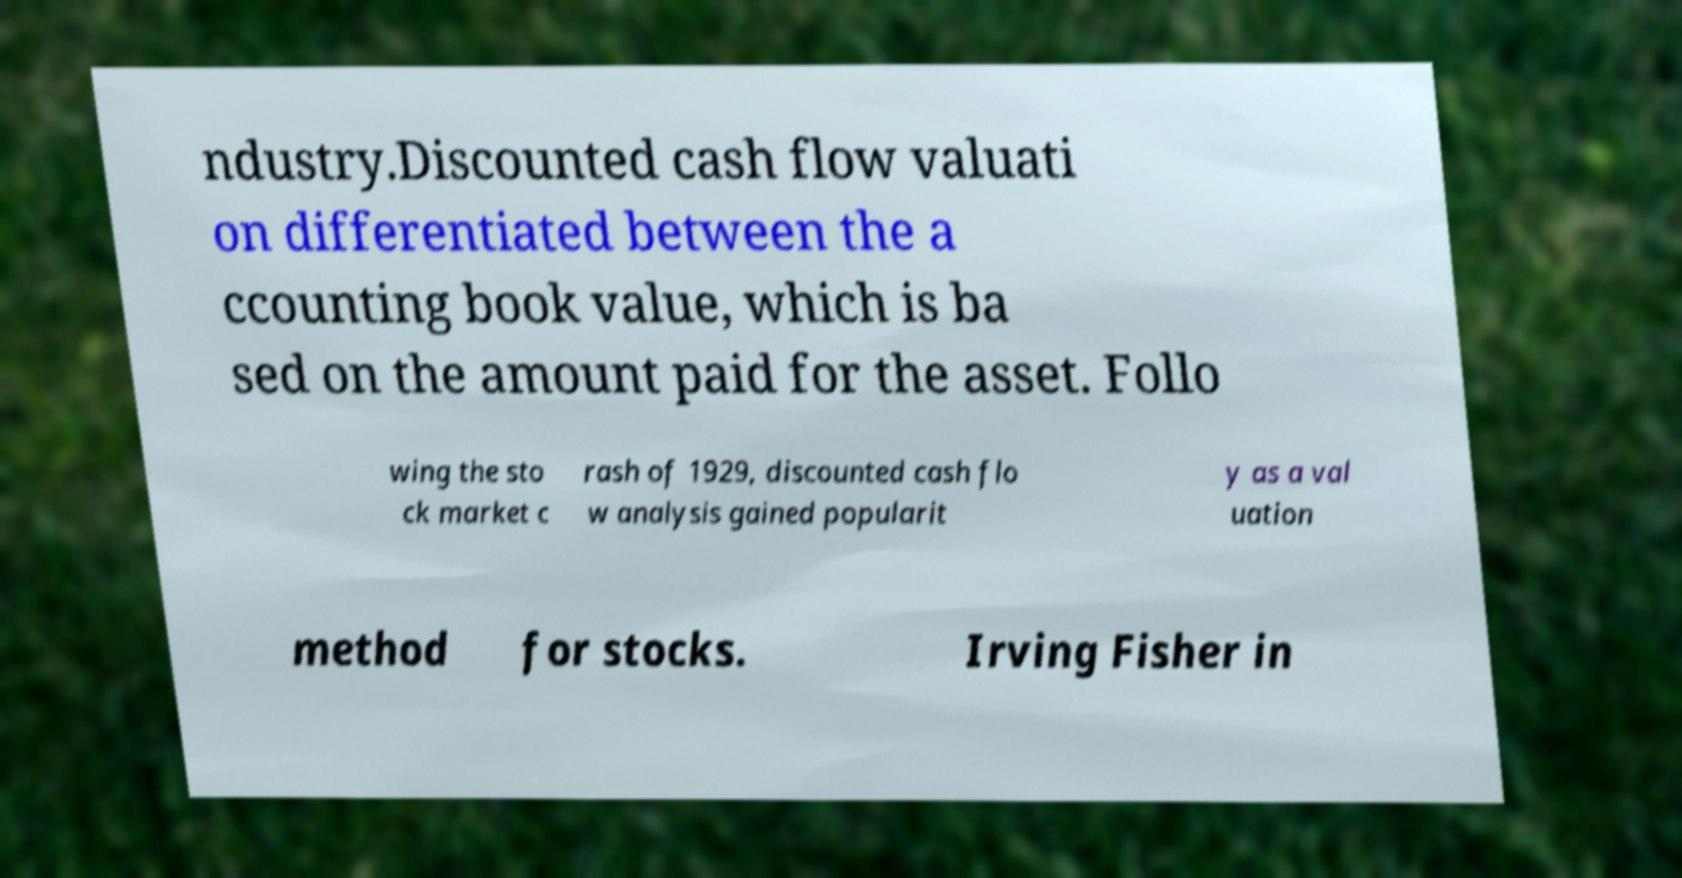What messages or text are displayed in this image? I need them in a readable, typed format. ndustry.Discounted cash flow valuati on differentiated between the a ccounting book value, which is ba sed on the amount paid for the asset. Follo wing the sto ck market c rash of 1929, discounted cash flo w analysis gained popularit y as a val uation method for stocks. Irving Fisher in 